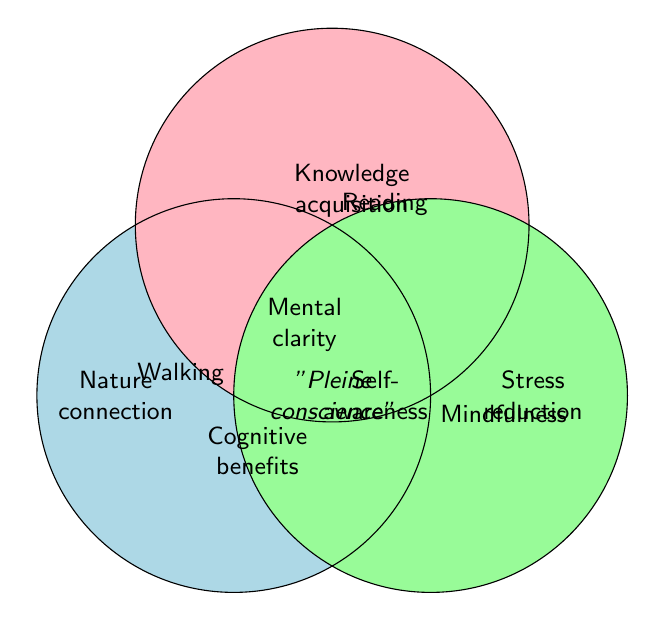What are the three primary categories in the Venn Diagram? The three primary categories are labeled on the circles in the diagram: Walking, Reading, and Mindfulness.
Answer: Walking, Reading, Mindfulness Which benefit is shared by all three activities? By examining the center of the diagram, where all three circles overlap, the shared benefit listed is "Pleine conscience" practice.
Answer: "Pleine conscience" practice What benefit is unique to Walking and not shared with Reading or Mindfulness? Look for benefits inside the Walking circle but outside the overlaps with Reading and Mindfulness. One of the benefits listed is "Nature connection".
Answer: Nature connection Which benefit is shared between Walking and Mindfulness, but not Reading? Locate the area where the Walking and Mindfulness circles overlap, excluding the overlap with Reading. The benefit listed there is "Self-awareness".
Answer: Self-awareness How many benefits are provided by Mindfulness alone? Identify the benefits inside the Mindfulness circle that do not overlap with either Walking or Reading. The benefits are: Stress reduction, Emotional balance, Present moment focus, Anxiety relief, Inner peace, Breathing awareness, Mood enhancement, and Productivity boost. Counting these yields eight unique benefits.
Answer: 8 